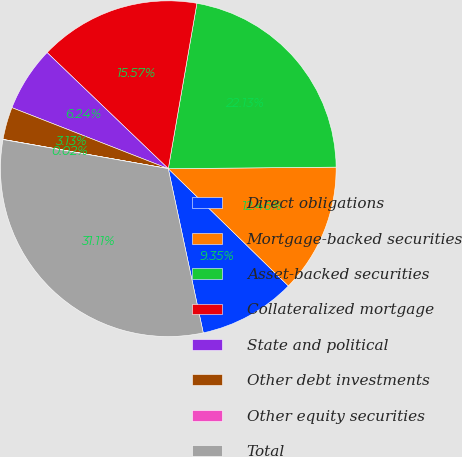Convert chart. <chart><loc_0><loc_0><loc_500><loc_500><pie_chart><fcel>Direct obligations<fcel>Mortgage-backed securities<fcel>Asset-backed securities<fcel>Collateralized mortgage<fcel>State and political<fcel>Other debt investments<fcel>Other equity securities<fcel>Total<nl><fcel>9.35%<fcel>12.46%<fcel>22.13%<fcel>15.57%<fcel>6.24%<fcel>3.13%<fcel>0.02%<fcel>31.12%<nl></chart> 